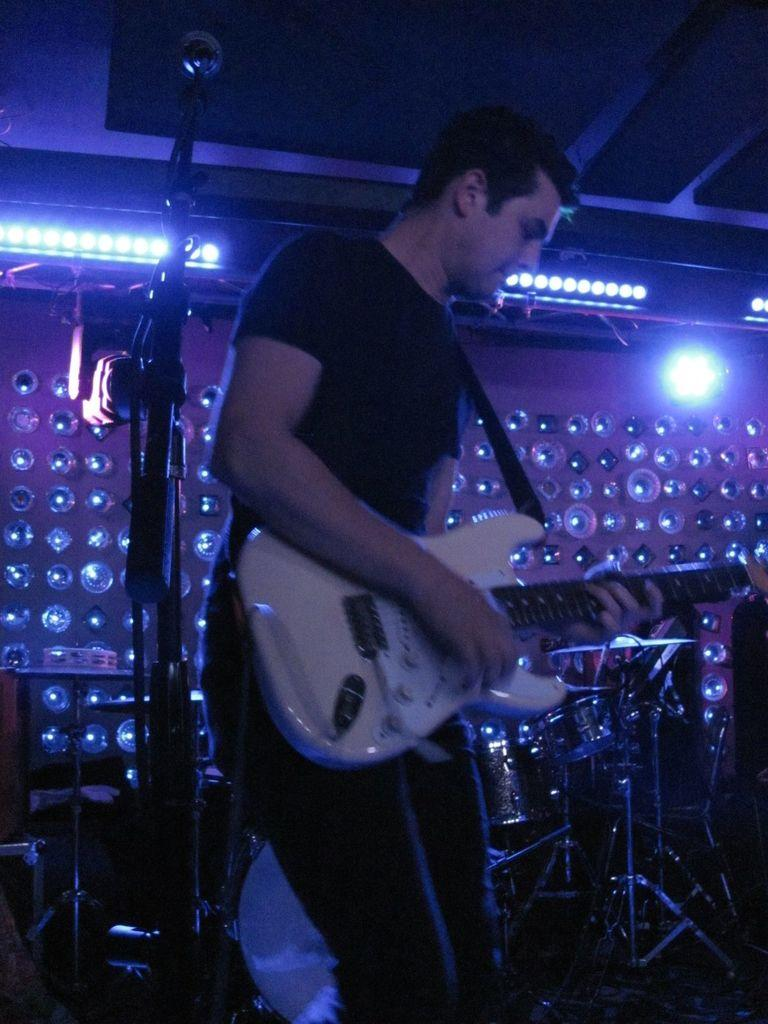What is the man in the image holding? The man is holding a guitar in the image. What color is the T-shirt the man is wearing? The man is wearing a black T-shirt. What color are the pants the man is wearing? The man is wearing black pants. What can be seen in the background of the image? There is a light and lights associated with musical instruments in the background of the image. What type of bread is the man using to play the guitar in the image? There is no bread present in the image, and the man is not using any bread to play the guitar. 